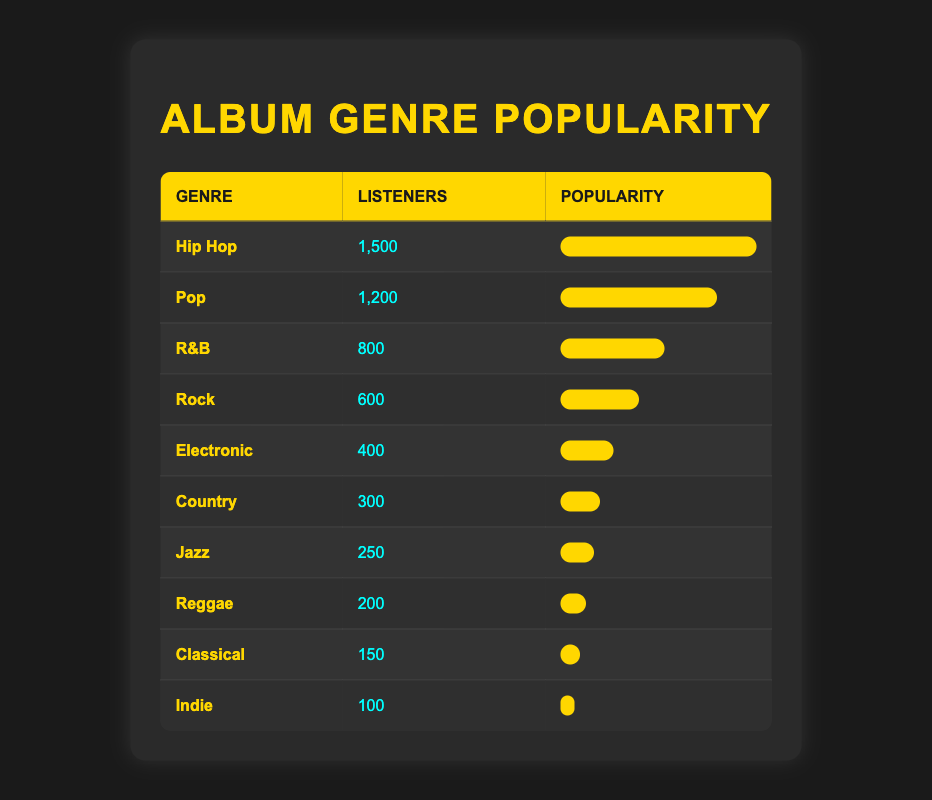What is the genre with the highest listeners count? The genre with the highest listeners count is identified by looking for the maximum value in the "listeners_count" column. From the table, "Hip Hop" has 1,500 listeners, which is the highest.
Answer: Hip Hop How many listeners does the Pop genre have? The number of listeners for the Pop genre can be directly found in the table under the "listeners_count" column. It shows that Pop has 1,200 listeners.
Answer: 1,200 What is the total number of listeners for Rock, Electronic, and Country genres combined? To find the total number of listeners for Rock, Electronic, and Country genres, add up their listeners: Rock (600) + Electronic (400) + Country (300) = 600 + 400 + 300 = 1300.
Answer: 1300 Is the number of listeners for Jazz greater than that for Reggae? To answer this, we need to compare the listeners counts for Jazz and Reggae. Jazz has 250 listeners while Reggae has 200. Since 250 is greater than 200, the statement is true.
Answer: Yes What is the average number of listeners across all genres listed? To calculate the average, first find the total number of listeners by adding all the values: 1,500 + 1,200 + 800 + 600 + 400 + 300 + 250 + 200 + 150 + 100 = 5,550. There are 10 genres, so the average number of listeners is 5,550 / 10 = 555.
Answer: 555 Which two genres have the closest number of listeners and what are their counts? First, we compare the listeners counts for all genres to find the two with the closest values. Jazz has 250 and Reggae has 200; these are the closest, with a difference of 50 listeners.
Answer: Jazz (250) and Reggae (200) How many genres have more than 500 listeners? We can count how many genres have a listeners count greater than 500. The genres that meet this criterion are Hip Hop (1,500), Pop (1,200), R&B (800), and Rock (600). That totals four genres.
Answer: 4 What is the difference in listeners count between Pop and Electronic genres? To find the difference, we subtract the listeners count of Electronic from that of Pop. Pop has 1,200 listeners and Electronic has 400, so the difference is 1,200 - 400 = 800.
Answer: 800 Is Indie the least popular genre among the listeners? By checking the "listeners_count" values, we see that Indie has 100 listeners, which is the lowest compared to all other genres in the table. Therefore, the statement is true.
Answer: Yes 